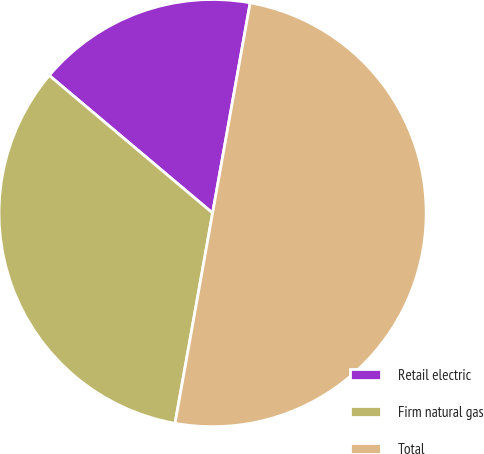Convert chart to OTSL. <chart><loc_0><loc_0><loc_500><loc_500><pie_chart><fcel>Retail electric<fcel>Firm natural gas<fcel>Total<nl><fcel>16.67%<fcel>33.33%<fcel>50.0%<nl></chart> 